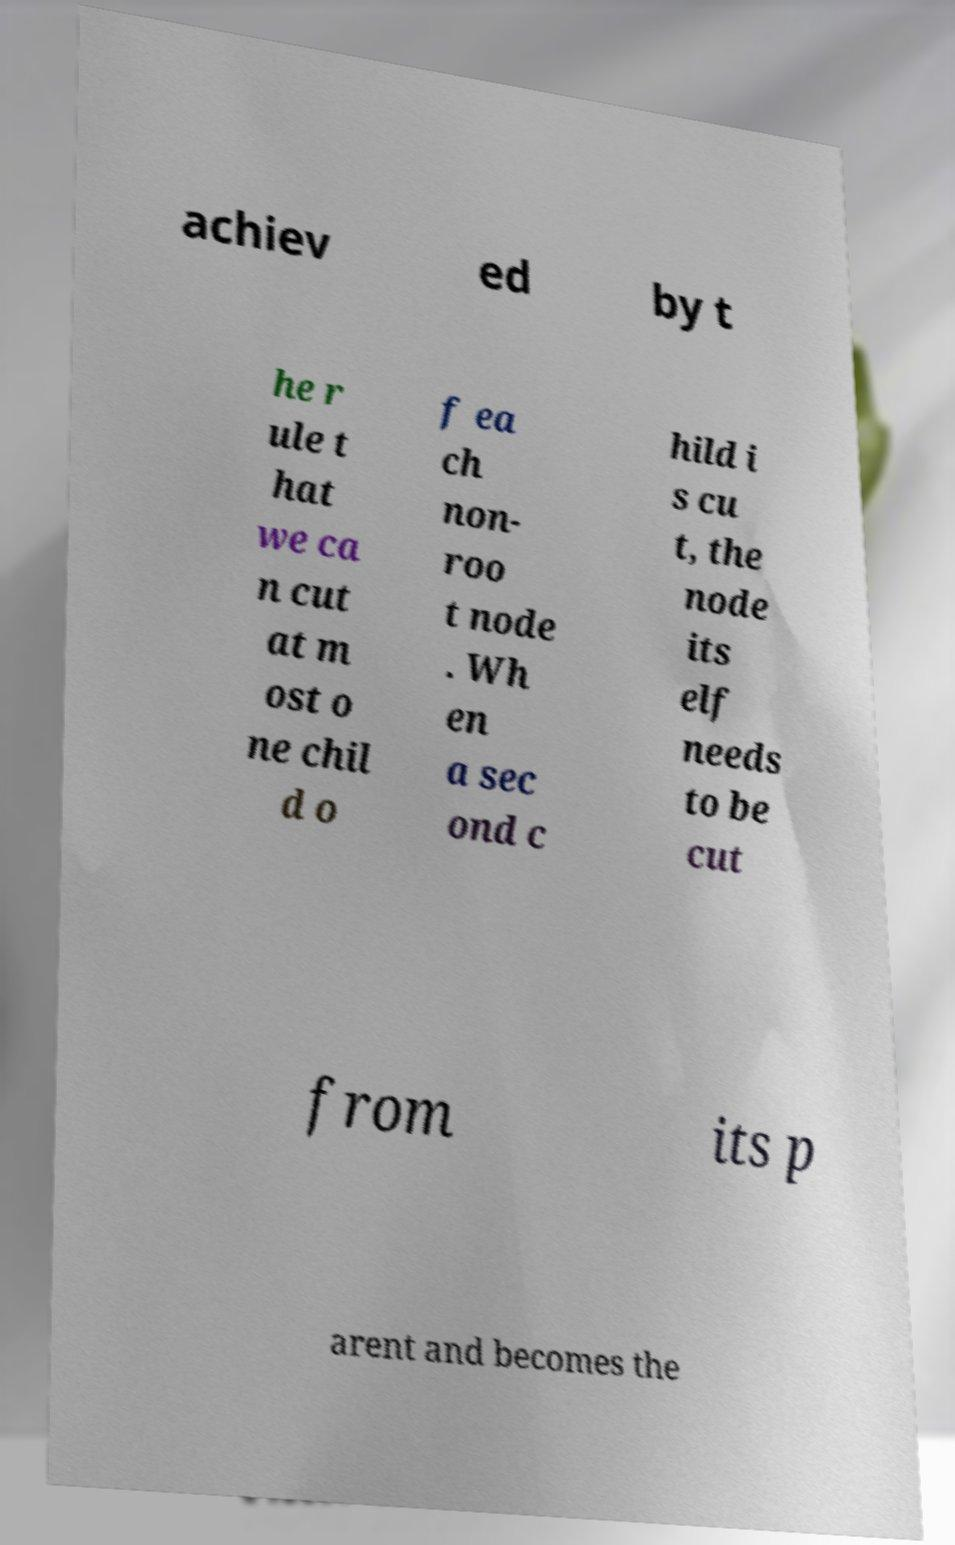What messages or text are displayed in this image? I need them in a readable, typed format. achiev ed by t he r ule t hat we ca n cut at m ost o ne chil d o f ea ch non- roo t node . Wh en a sec ond c hild i s cu t, the node its elf needs to be cut from its p arent and becomes the 